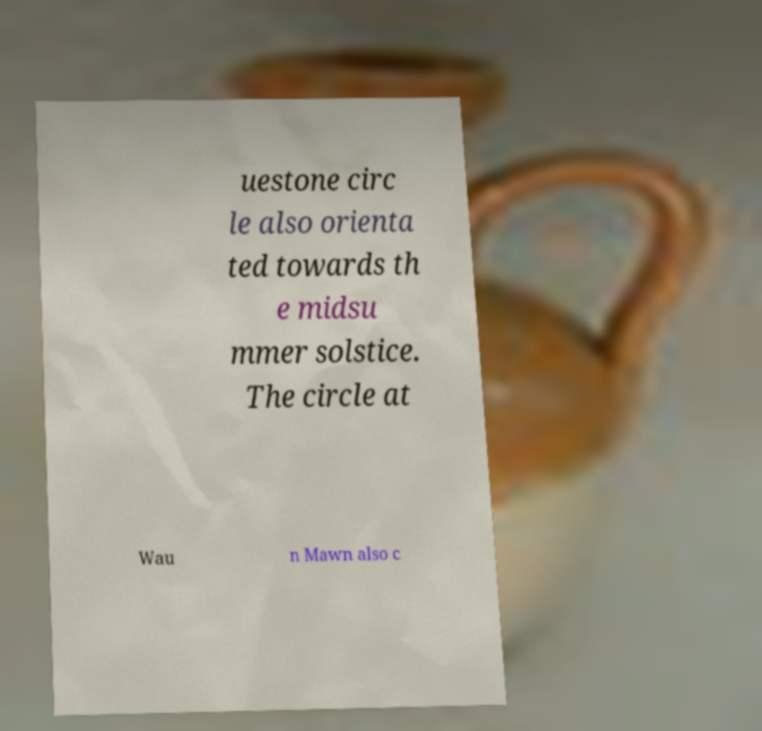There's text embedded in this image that I need extracted. Can you transcribe it verbatim? uestone circ le also orienta ted towards th e midsu mmer solstice. The circle at Wau n Mawn also c 